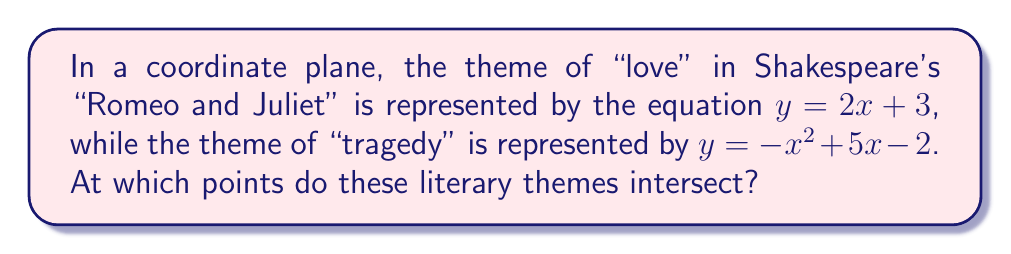Can you answer this question? To find the intersection points, we need to solve the system of equations:

1) $y = 2x + 3$
2) $y = -x^2 + 5x - 2$

Step 1: Set the equations equal to each other.
$2x + 3 = -x^2 + 5x - 2$

Step 2: Rearrange the equation to standard form.
$x^2 + 3x - 5 = 0$

Step 3: Use the quadratic formula to solve for x.
$x = \frac{-b \pm \sqrt{b^2 - 4ac}}{2a}$

Where $a = 1$, $b = 3$, and $c = -5$

$x = \frac{-3 \pm \sqrt{3^2 - 4(1)(-5)}}{2(1)}$
$x = \frac{-3 \pm \sqrt{9 + 20}}{2}$
$x = \frac{-3 \pm \sqrt{29}}{2}$

Step 4: Calculate the two x-values.
$x_1 = \frac{-3 + \sqrt{29}}{2} \approx 1.19$
$x_2 = \frac{-3 - \sqrt{29}}{2} \approx -4.19$

Step 5: Find the corresponding y-values using either of the original equations. Let's use $y = 2x + 3$.

For $x_1$: $y_1 = 2(1.19) + 3 \approx 5.38$
For $x_2$: $y_2 = 2(-4.19) + 3 \approx -5.38$

Therefore, the intersection points are approximately (1.19, 5.38) and (-4.19, -5.38).
Answer: $(\frac{-3 + \sqrt{29}}{2}, \frac{-3 + \sqrt{29}}{2} + 3)$ and $(\frac{-3 - \sqrt{29}}{2}, \frac{-3 - \sqrt{29}}{2} + 3)$ 